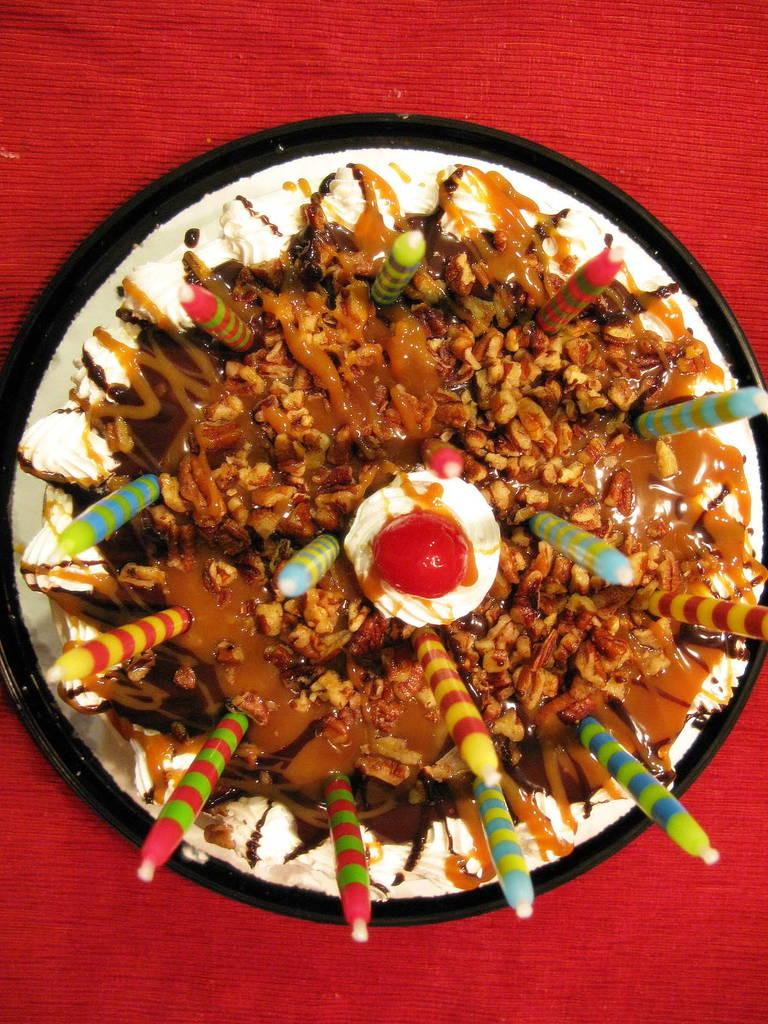What is on the plate that is visible in the image? There is a cake on the plate in the image. What decorations are on the cake? There are candles and a cherry on the cake on the cake. What is at the bottom of the image? There is a cloth at the bottom of the image. How many shoes are visible on the cake in the image? There are no shoes present on the cake or in the image. Are there any icicles hanging from the candles on the cake? There are no icicles visible in the image; the candles are on a cake with a cherry. 